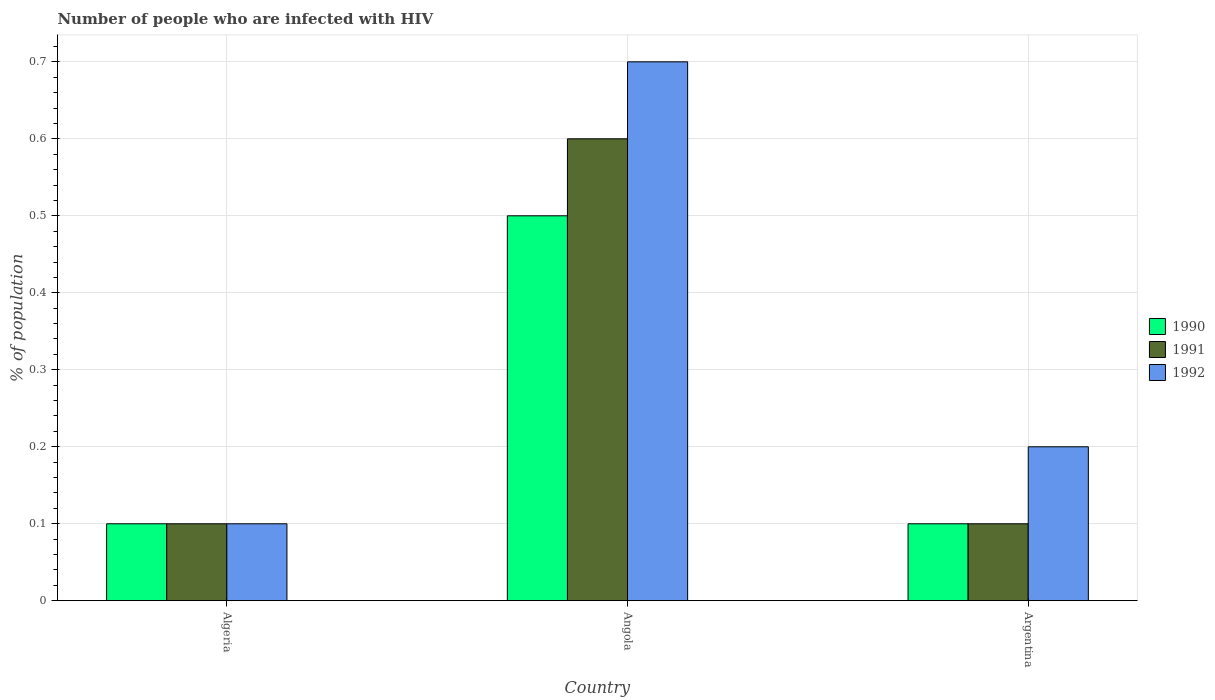How many different coloured bars are there?
Offer a terse response. 3. How many bars are there on the 1st tick from the right?
Offer a very short reply. 3. Across all countries, what is the maximum percentage of HIV infected population in in 1990?
Offer a terse response. 0.5. In which country was the percentage of HIV infected population in in 1990 maximum?
Offer a terse response. Angola. In which country was the percentage of HIV infected population in in 1990 minimum?
Give a very brief answer. Algeria. What is the average percentage of HIV infected population in in 1992 per country?
Your answer should be very brief. 0.33. What is the difference between the percentage of HIV infected population in of/in 1991 and percentage of HIV infected population in of/in 1990 in Argentina?
Offer a very short reply. 0. What is the ratio of the percentage of HIV infected population in in 1992 in Angola to that in Argentina?
Your answer should be compact. 3.5. Is the percentage of HIV infected population in in 1992 in Algeria less than that in Angola?
Offer a very short reply. Yes. Is the difference between the percentage of HIV infected population in in 1991 in Angola and Argentina greater than the difference between the percentage of HIV infected population in in 1990 in Angola and Argentina?
Offer a very short reply. Yes. Is the sum of the percentage of HIV infected population in in 1992 in Algeria and Argentina greater than the maximum percentage of HIV infected population in in 1991 across all countries?
Ensure brevity in your answer.  No. What does the 3rd bar from the right in Algeria represents?
Keep it short and to the point. 1990. Are all the bars in the graph horizontal?
Offer a very short reply. No. How many countries are there in the graph?
Give a very brief answer. 3. What is the difference between two consecutive major ticks on the Y-axis?
Provide a succinct answer. 0.1. Does the graph contain any zero values?
Offer a terse response. No. Where does the legend appear in the graph?
Your answer should be very brief. Center right. What is the title of the graph?
Make the answer very short. Number of people who are infected with HIV. What is the label or title of the Y-axis?
Your answer should be very brief. % of population. What is the % of population of 1990 in Algeria?
Keep it short and to the point. 0.1. What is the % of population in 1991 in Algeria?
Keep it short and to the point. 0.1. What is the % of population of 1990 in Angola?
Provide a succinct answer. 0.5. What is the % of population of 1990 in Argentina?
Your answer should be compact. 0.1. What is the % of population of 1991 in Argentina?
Offer a terse response. 0.1. What is the % of population in 1992 in Argentina?
Make the answer very short. 0.2. Across all countries, what is the maximum % of population in 1990?
Provide a short and direct response. 0.5. Across all countries, what is the minimum % of population in 1990?
Provide a short and direct response. 0.1. Across all countries, what is the minimum % of population of 1992?
Your answer should be compact. 0.1. What is the total % of population of 1990 in the graph?
Keep it short and to the point. 0.7. What is the total % of population of 1992 in the graph?
Ensure brevity in your answer.  1. What is the difference between the % of population of 1991 in Algeria and that in Angola?
Provide a succinct answer. -0.5. What is the difference between the % of population of 1991 in Algeria and that in Argentina?
Your answer should be compact. 0. What is the difference between the % of population of 1992 in Algeria and that in Argentina?
Make the answer very short. -0.1. What is the difference between the % of population in 1990 in Angola and that in Argentina?
Provide a succinct answer. 0.4. What is the difference between the % of population of 1991 in Angola and that in Argentina?
Offer a terse response. 0.5. What is the difference between the % of population in 1992 in Angola and that in Argentina?
Your response must be concise. 0.5. What is the difference between the % of population of 1990 in Algeria and the % of population of 1991 in Angola?
Your response must be concise. -0.5. What is the difference between the % of population in 1990 in Algeria and the % of population in 1991 in Argentina?
Provide a succinct answer. 0. What is the difference between the % of population of 1991 in Algeria and the % of population of 1992 in Argentina?
Your answer should be compact. -0.1. What is the difference between the % of population in 1991 in Angola and the % of population in 1992 in Argentina?
Offer a very short reply. 0.4. What is the average % of population in 1990 per country?
Ensure brevity in your answer.  0.23. What is the average % of population of 1991 per country?
Keep it short and to the point. 0.27. What is the average % of population of 1992 per country?
Ensure brevity in your answer.  0.33. What is the difference between the % of population of 1990 and % of population of 1992 in Algeria?
Offer a terse response. 0. What is the difference between the % of population of 1990 and % of population of 1992 in Angola?
Your response must be concise. -0.2. What is the difference between the % of population of 1991 and % of population of 1992 in Argentina?
Offer a very short reply. -0.1. What is the ratio of the % of population of 1990 in Algeria to that in Angola?
Make the answer very short. 0.2. What is the ratio of the % of population in 1991 in Algeria to that in Angola?
Your answer should be very brief. 0.17. What is the ratio of the % of population of 1992 in Algeria to that in Angola?
Make the answer very short. 0.14. What is the ratio of the % of population in 1990 in Angola to that in Argentina?
Give a very brief answer. 5. What is the ratio of the % of population in 1991 in Angola to that in Argentina?
Your answer should be compact. 6. What is the difference between the highest and the second highest % of population in 1991?
Offer a terse response. 0.5. What is the difference between the highest and the lowest % of population of 1990?
Make the answer very short. 0.4. 